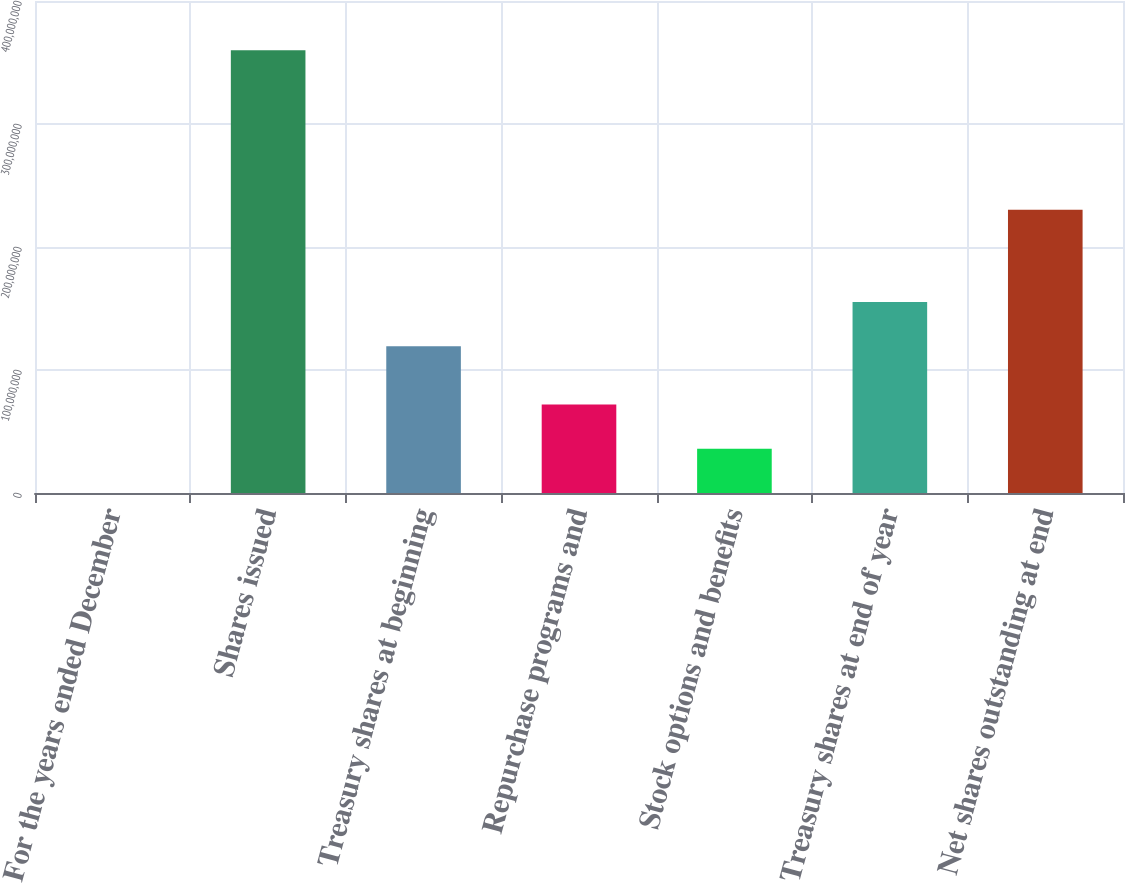Convert chart. <chart><loc_0><loc_0><loc_500><loc_500><bar_chart><fcel>For the years ended December<fcel>Shares issued<fcel>Treasury shares at beginning<fcel>Repurchase programs and<fcel>Stock options and benefits<fcel>Treasury shares at end of year<fcel>Net shares outstanding at end<nl><fcel>2006<fcel>3.59902e+08<fcel>1.19378e+08<fcel>7.1982e+07<fcel>3.5992e+07<fcel>1.55368e+08<fcel>2.30264e+08<nl></chart> 